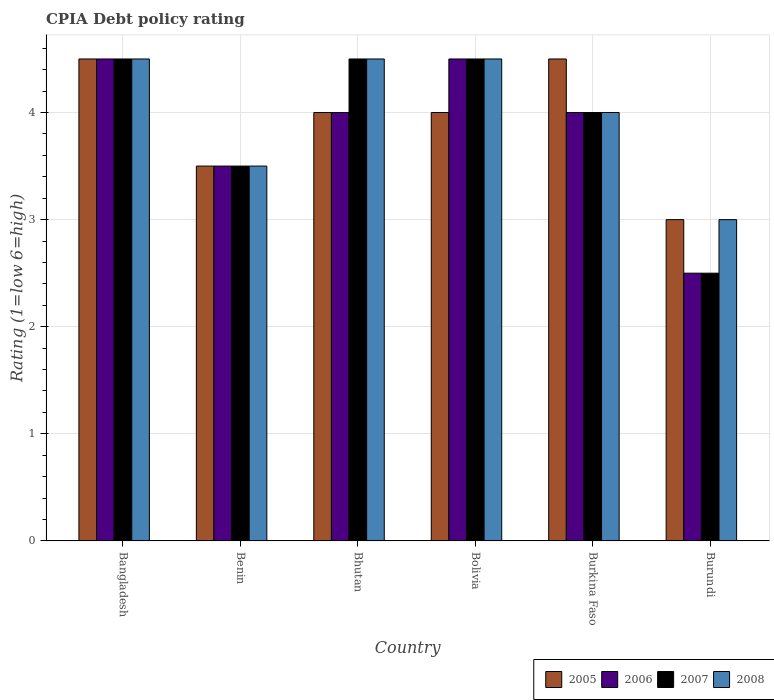Are the number of bars on each tick of the X-axis equal?
Ensure brevity in your answer.  Yes. How many bars are there on the 1st tick from the left?
Your response must be concise. 4. What is the label of the 1st group of bars from the left?
Ensure brevity in your answer.  Bangladesh. What is the CPIA rating in 2005 in Bolivia?
Your answer should be very brief. 4. Across all countries, what is the maximum CPIA rating in 2008?
Your response must be concise. 4.5. In which country was the CPIA rating in 2005 maximum?
Make the answer very short. Bangladesh. In which country was the CPIA rating in 2005 minimum?
Your response must be concise. Burundi. What is the total CPIA rating in 2005 in the graph?
Make the answer very short. 23.5. What is the difference between the CPIA rating of/in 2005 and CPIA rating of/in 2006 in Bolivia?
Give a very brief answer. -0.5. What is the difference between the highest and the second highest CPIA rating in 2005?
Your answer should be compact. 0.5. Is it the case that in every country, the sum of the CPIA rating in 2006 and CPIA rating in 2005 is greater than the sum of CPIA rating in 2008 and CPIA rating in 2007?
Give a very brief answer. No. Are all the bars in the graph horizontal?
Provide a short and direct response. No. How many countries are there in the graph?
Provide a short and direct response. 6. What is the difference between two consecutive major ticks on the Y-axis?
Provide a succinct answer. 1. Are the values on the major ticks of Y-axis written in scientific E-notation?
Give a very brief answer. No. Does the graph contain any zero values?
Ensure brevity in your answer.  No. How are the legend labels stacked?
Offer a very short reply. Horizontal. What is the title of the graph?
Ensure brevity in your answer.  CPIA Debt policy rating. What is the label or title of the Y-axis?
Offer a terse response. Rating (1=low 6=high). What is the Rating (1=low 6=high) of 2005 in Bangladesh?
Your response must be concise. 4.5. What is the Rating (1=low 6=high) in 2007 in Bangladesh?
Your answer should be compact. 4.5. What is the Rating (1=low 6=high) in 2008 in Bangladesh?
Your answer should be compact. 4.5. What is the Rating (1=low 6=high) of 2008 in Benin?
Offer a terse response. 3.5. What is the Rating (1=low 6=high) in 2005 in Bhutan?
Your answer should be compact. 4. What is the Rating (1=low 6=high) in 2006 in Bhutan?
Your answer should be compact. 4. What is the Rating (1=low 6=high) in 2008 in Bhutan?
Ensure brevity in your answer.  4.5. What is the Rating (1=low 6=high) in 2006 in Burkina Faso?
Your response must be concise. 4. What is the Rating (1=low 6=high) in 2007 in Burkina Faso?
Offer a terse response. 4. What is the Rating (1=low 6=high) of 2006 in Burundi?
Make the answer very short. 2.5. What is the Rating (1=low 6=high) of 2007 in Burundi?
Make the answer very short. 2.5. What is the Rating (1=low 6=high) of 2008 in Burundi?
Keep it short and to the point. 3. Across all countries, what is the maximum Rating (1=low 6=high) in 2005?
Ensure brevity in your answer.  4.5. Across all countries, what is the maximum Rating (1=low 6=high) of 2006?
Provide a succinct answer. 4.5. Across all countries, what is the minimum Rating (1=low 6=high) of 2006?
Give a very brief answer. 2.5. What is the total Rating (1=low 6=high) of 2006 in the graph?
Offer a very short reply. 23. What is the total Rating (1=low 6=high) in 2007 in the graph?
Your answer should be compact. 23.5. What is the difference between the Rating (1=low 6=high) of 2007 in Bangladesh and that in Benin?
Offer a very short reply. 1. What is the difference between the Rating (1=low 6=high) in 2008 in Bangladesh and that in Benin?
Your response must be concise. 1. What is the difference between the Rating (1=low 6=high) in 2005 in Bangladesh and that in Bhutan?
Offer a very short reply. 0.5. What is the difference between the Rating (1=low 6=high) in 2006 in Bangladesh and that in Bhutan?
Provide a short and direct response. 0.5. What is the difference between the Rating (1=low 6=high) of 2006 in Bangladesh and that in Bolivia?
Your answer should be compact. 0. What is the difference between the Rating (1=low 6=high) in 2007 in Bangladesh and that in Bolivia?
Provide a short and direct response. 0. What is the difference between the Rating (1=low 6=high) of 2007 in Bangladesh and that in Burkina Faso?
Ensure brevity in your answer.  0.5. What is the difference between the Rating (1=low 6=high) of 2006 in Bangladesh and that in Burundi?
Your response must be concise. 2. What is the difference between the Rating (1=low 6=high) of 2007 in Bangladesh and that in Burundi?
Make the answer very short. 2. What is the difference between the Rating (1=low 6=high) of 2005 in Benin and that in Bhutan?
Give a very brief answer. -0.5. What is the difference between the Rating (1=low 6=high) of 2007 in Benin and that in Bhutan?
Your answer should be compact. -1. What is the difference between the Rating (1=low 6=high) of 2005 in Benin and that in Bolivia?
Provide a succinct answer. -0.5. What is the difference between the Rating (1=low 6=high) of 2007 in Benin and that in Bolivia?
Make the answer very short. -1. What is the difference between the Rating (1=low 6=high) of 2008 in Benin and that in Bolivia?
Offer a terse response. -1. What is the difference between the Rating (1=low 6=high) of 2005 in Benin and that in Burkina Faso?
Offer a very short reply. -1. What is the difference between the Rating (1=low 6=high) of 2008 in Benin and that in Burundi?
Ensure brevity in your answer.  0.5. What is the difference between the Rating (1=low 6=high) of 2005 in Bhutan and that in Bolivia?
Make the answer very short. 0. What is the difference between the Rating (1=low 6=high) of 2006 in Bhutan and that in Bolivia?
Make the answer very short. -0.5. What is the difference between the Rating (1=low 6=high) in 2007 in Bhutan and that in Bolivia?
Your answer should be very brief. 0. What is the difference between the Rating (1=low 6=high) in 2006 in Bhutan and that in Burkina Faso?
Your response must be concise. 0. What is the difference between the Rating (1=low 6=high) of 2007 in Bhutan and that in Burkina Faso?
Give a very brief answer. 0.5. What is the difference between the Rating (1=low 6=high) of 2008 in Bhutan and that in Burkina Faso?
Keep it short and to the point. 0.5. What is the difference between the Rating (1=low 6=high) in 2007 in Bhutan and that in Burundi?
Ensure brevity in your answer.  2. What is the difference between the Rating (1=low 6=high) in 2006 in Bolivia and that in Burkina Faso?
Provide a short and direct response. 0.5. What is the difference between the Rating (1=low 6=high) of 2008 in Bolivia and that in Burkina Faso?
Provide a succinct answer. 0.5. What is the difference between the Rating (1=low 6=high) in 2006 in Bolivia and that in Burundi?
Your response must be concise. 2. What is the difference between the Rating (1=low 6=high) in 2008 in Bolivia and that in Burundi?
Your response must be concise. 1.5. What is the difference between the Rating (1=low 6=high) in 2007 in Burkina Faso and that in Burundi?
Provide a short and direct response. 1.5. What is the difference between the Rating (1=low 6=high) of 2005 in Bangladesh and the Rating (1=low 6=high) of 2006 in Benin?
Offer a terse response. 1. What is the difference between the Rating (1=low 6=high) of 2005 in Bangladesh and the Rating (1=low 6=high) of 2007 in Benin?
Your response must be concise. 1. What is the difference between the Rating (1=low 6=high) of 2006 in Bangladesh and the Rating (1=low 6=high) of 2007 in Benin?
Give a very brief answer. 1. What is the difference between the Rating (1=low 6=high) in 2007 in Bangladesh and the Rating (1=low 6=high) in 2008 in Benin?
Offer a very short reply. 1. What is the difference between the Rating (1=low 6=high) of 2005 in Bangladesh and the Rating (1=low 6=high) of 2006 in Bhutan?
Your answer should be very brief. 0.5. What is the difference between the Rating (1=low 6=high) in 2006 in Bangladesh and the Rating (1=low 6=high) in 2007 in Bhutan?
Provide a succinct answer. 0. What is the difference between the Rating (1=low 6=high) in 2006 in Bangladesh and the Rating (1=low 6=high) in 2008 in Bhutan?
Offer a terse response. 0. What is the difference between the Rating (1=low 6=high) of 2006 in Bangladesh and the Rating (1=low 6=high) of 2007 in Bolivia?
Make the answer very short. 0. What is the difference between the Rating (1=low 6=high) of 2006 in Bangladesh and the Rating (1=low 6=high) of 2008 in Bolivia?
Your answer should be compact. 0. What is the difference between the Rating (1=low 6=high) of 2005 in Bangladesh and the Rating (1=low 6=high) of 2007 in Burkina Faso?
Keep it short and to the point. 0.5. What is the difference between the Rating (1=low 6=high) in 2006 in Bangladesh and the Rating (1=low 6=high) in 2008 in Burkina Faso?
Offer a very short reply. 0.5. What is the difference between the Rating (1=low 6=high) in 2007 in Bangladesh and the Rating (1=low 6=high) in 2008 in Burkina Faso?
Provide a short and direct response. 0.5. What is the difference between the Rating (1=low 6=high) of 2005 in Bangladesh and the Rating (1=low 6=high) of 2006 in Burundi?
Offer a very short reply. 2. What is the difference between the Rating (1=low 6=high) in 2005 in Bangladesh and the Rating (1=low 6=high) in 2008 in Burundi?
Offer a terse response. 1.5. What is the difference between the Rating (1=low 6=high) of 2006 in Bangladesh and the Rating (1=low 6=high) of 2007 in Burundi?
Your answer should be very brief. 2. What is the difference between the Rating (1=low 6=high) in 2005 in Benin and the Rating (1=low 6=high) in 2006 in Bhutan?
Your answer should be very brief. -0.5. What is the difference between the Rating (1=low 6=high) in 2005 in Benin and the Rating (1=low 6=high) in 2007 in Bhutan?
Give a very brief answer. -1. What is the difference between the Rating (1=low 6=high) in 2006 in Benin and the Rating (1=low 6=high) in 2008 in Bhutan?
Your response must be concise. -1. What is the difference between the Rating (1=low 6=high) of 2007 in Benin and the Rating (1=low 6=high) of 2008 in Bhutan?
Provide a short and direct response. -1. What is the difference between the Rating (1=low 6=high) of 2006 in Benin and the Rating (1=low 6=high) of 2008 in Bolivia?
Keep it short and to the point. -1. What is the difference between the Rating (1=low 6=high) in 2005 in Benin and the Rating (1=low 6=high) in 2006 in Burkina Faso?
Offer a very short reply. -0.5. What is the difference between the Rating (1=low 6=high) of 2005 in Benin and the Rating (1=low 6=high) of 2008 in Burkina Faso?
Your answer should be compact. -0.5. What is the difference between the Rating (1=low 6=high) in 2006 in Benin and the Rating (1=low 6=high) in 2007 in Burkina Faso?
Give a very brief answer. -0.5. What is the difference between the Rating (1=low 6=high) of 2006 in Benin and the Rating (1=low 6=high) of 2008 in Burkina Faso?
Your response must be concise. -0.5. What is the difference between the Rating (1=low 6=high) in 2007 in Benin and the Rating (1=low 6=high) in 2008 in Burkina Faso?
Your response must be concise. -0.5. What is the difference between the Rating (1=low 6=high) in 2005 in Benin and the Rating (1=low 6=high) in 2006 in Burundi?
Offer a very short reply. 1. What is the difference between the Rating (1=low 6=high) in 2005 in Benin and the Rating (1=low 6=high) in 2007 in Burundi?
Make the answer very short. 1. What is the difference between the Rating (1=low 6=high) in 2005 in Benin and the Rating (1=low 6=high) in 2008 in Burundi?
Offer a terse response. 0.5. What is the difference between the Rating (1=low 6=high) in 2006 in Benin and the Rating (1=low 6=high) in 2007 in Burundi?
Make the answer very short. 1. What is the difference between the Rating (1=low 6=high) in 2007 in Benin and the Rating (1=low 6=high) in 2008 in Burundi?
Your response must be concise. 0.5. What is the difference between the Rating (1=low 6=high) of 2005 in Bhutan and the Rating (1=low 6=high) of 2006 in Bolivia?
Your answer should be compact. -0.5. What is the difference between the Rating (1=low 6=high) in 2005 in Bhutan and the Rating (1=low 6=high) in 2007 in Bolivia?
Your response must be concise. -0.5. What is the difference between the Rating (1=low 6=high) in 2006 in Bhutan and the Rating (1=low 6=high) in 2007 in Bolivia?
Your answer should be very brief. -0.5. What is the difference between the Rating (1=low 6=high) in 2006 in Bhutan and the Rating (1=low 6=high) in 2008 in Bolivia?
Keep it short and to the point. -0.5. What is the difference between the Rating (1=low 6=high) in 2005 in Bhutan and the Rating (1=low 6=high) in 2007 in Burkina Faso?
Ensure brevity in your answer.  0. What is the difference between the Rating (1=low 6=high) of 2006 in Bhutan and the Rating (1=low 6=high) of 2007 in Burkina Faso?
Your response must be concise. 0. What is the difference between the Rating (1=low 6=high) in 2006 in Bhutan and the Rating (1=low 6=high) in 2008 in Burkina Faso?
Offer a terse response. 0. What is the difference between the Rating (1=low 6=high) of 2006 in Bhutan and the Rating (1=low 6=high) of 2007 in Burundi?
Ensure brevity in your answer.  1.5. What is the difference between the Rating (1=low 6=high) of 2006 in Bhutan and the Rating (1=low 6=high) of 2008 in Burundi?
Your response must be concise. 1. What is the difference between the Rating (1=low 6=high) of 2005 in Bolivia and the Rating (1=low 6=high) of 2006 in Burkina Faso?
Your response must be concise. 0. What is the difference between the Rating (1=low 6=high) in 2006 in Bolivia and the Rating (1=low 6=high) in 2008 in Burkina Faso?
Your answer should be compact. 0.5. What is the difference between the Rating (1=low 6=high) of 2007 in Bolivia and the Rating (1=low 6=high) of 2008 in Burkina Faso?
Provide a short and direct response. 0.5. What is the difference between the Rating (1=low 6=high) of 2005 in Bolivia and the Rating (1=low 6=high) of 2006 in Burundi?
Your answer should be compact. 1.5. What is the difference between the Rating (1=low 6=high) of 2007 in Bolivia and the Rating (1=low 6=high) of 2008 in Burundi?
Provide a short and direct response. 1.5. What is the difference between the Rating (1=low 6=high) of 2005 in Burkina Faso and the Rating (1=low 6=high) of 2006 in Burundi?
Offer a very short reply. 2. What is the difference between the Rating (1=low 6=high) of 2005 in Burkina Faso and the Rating (1=low 6=high) of 2007 in Burundi?
Offer a very short reply. 2. What is the difference between the Rating (1=low 6=high) of 2006 in Burkina Faso and the Rating (1=low 6=high) of 2008 in Burundi?
Make the answer very short. 1. What is the average Rating (1=low 6=high) of 2005 per country?
Keep it short and to the point. 3.92. What is the average Rating (1=low 6=high) of 2006 per country?
Provide a short and direct response. 3.83. What is the average Rating (1=low 6=high) in 2007 per country?
Keep it short and to the point. 3.92. What is the average Rating (1=low 6=high) in 2008 per country?
Provide a succinct answer. 4. What is the difference between the Rating (1=low 6=high) of 2005 and Rating (1=low 6=high) of 2008 in Bangladesh?
Your answer should be very brief. 0. What is the difference between the Rating (1=low 6=high) in 2006 and Rating (1=low 6=high) in 2007 in Bangladesh?
Keep it short and to the point. 0. What is the difference between the Rating (1=low 6=high) of 2006 and Rating (1=low 6=high) of 2008 in Bangladesh?
Make the answer very short. 0. What is the difference between the Rating (1=low 6=high) of 2006 and Rating (1=low 6=high) of 2008 in Benin?
Keep it short and to the point. 0. What is the difference between the Rating (1=low 6=high) in 2007 and Rating (1=low 6=high) in 2008 in Benin?
Offer a terse response. 0. What is the difference between the Rating (1=low 6=high) of 2005 and Rating (1=low 6=high) of 2006 in Bhutan?
Ensure brevity in your answer.  0. What is the difference between the Rating (1=low 6=high) in 2005 and Rating (1=low 6=high) in 2007 in Bhutan?
Offer a terse response. -0.5. What is the difference between the Rating (1=low 6=high) of 2005 and Rating (1=low 6=high) of 2008 in Bhutan?
Give a very brief answer. -0.5. What is the difference between the Rating (1=low 6=high) of 2006 and Rating (1=low 6=high) of 2007 in Bhutan?
Keep it short and to the point. -0.5. What is the difference between the Rating (1=low 6=high) of 2007 and Rating (1=low 6=high) of 2008 in Bhutan?
Your answer should be very brief. 0. What is the difference between the Rating (1=low 6=high) of 2005 and Rating (1=low 6=high) of 2007 in Bolivia?
Give a very brief answer. -0.5. What is the difference between the Rating (1=low 6=high) in 2005 and Rating (1=low 6=high) in 2008 in Burkina Faso?
Offer a very short reply. 0.5. What is the difference between the Rating (1=low 6=high) of 2006 and Rating (1=low 6=high) of 2008 in Burkina Faso?
Keep it short and to the point. 0. What is the difference between the Rating (1=low 6=high) in 2005 and Rating (1=low 6=high) in 2008 in Burundi?
Provide a succinct answer. 0. What is the difference between the Rating (1=low 6=high) in 2006 and Rating (1=low 6=high) in 2007 in Burundi?
Provide a short and direct response. 0. What is the difference between the Rating (1=low 6=high) in 2007 and Rating (1=low 6=high) in 2008 in Burundi?
Ensure brevity in your answer.  -0.5. What is the ratio of the Rating (1=low 6=high) in 2005 in Bangladesh to that in Benin?
Provide a succinct answer. 1.29. What is the ratio of the Rating (1=low 6=high) of 2006 in Bangladesh to that in Benin?
Your response must be concise. 1.29. What is the ratio of the Rating (1=low 6=high) of 2008 in Bangladesh to that in Benin?
Ensure brevity in your answer.  1.29. What is the ratio of the Rating (1=low 6=high) of 2006 in Bangladesh to that in Bhutan?
Provide a succinct answer. 1.12. What is the ratio of the Rating (1=low 6=high) in 2007 in Bangladesh to that in Bhutan?
Give a very brief answer. 1. What is the ratio of the Rating (1=low 6=high) in 2005 in Bangladesh to that in Bolivia?
Your answer should be very brief. 1.12. What is the ratio of the Rating (1=low 6=high) in 2007 in Bangladesh to that in Bolivia?
Keep it short and to the point. 1. What is the ratio of the Rating (1=low 6=high) of 2008 in Bangladesh to that in Bolivia?
Give a very brief answer. 1. What is the ratio of the Rating (1=low 6=high) in 2005 in Bangladesh to that in Burkina Faso?
Make the answer very short. 1. What is the ratio of the Rating (1=low 6=high) in 2007 in Bangladesh to that in Burkina Faso?
Provide a succinct answer. 1.12. What is the ratio of the Rating (1=low 6=high) in 2005 in Bangladesh to that in Burundi?
Make the answer very short. 1.5. What is the ratio of the Rating (1=low 6=high) of 2006 in Bangladesh to that in Burundi?
Provide a succinct answer. 1.8. What is the ratio of the Rating (1=low 6=high) of 2006 in Benin to that in Bhutan?
Provide a succinct answer. 0.88. What is the ratio of the Rating (1=low 6=high) in 2008 in Benin to that in Bhutan?
Give a very brief answer. 0.78. What is the ratio of the Rating (1=low 6=high) in 2005 in Benin to that in Bolivia?
Keep it short and to the point. 0.88. What is the ratio of the Rating (1=low 6=high) in 2006 in Benin to that in Bolivia?
Provide a succinct answer. 0.78. What is the ratio of the Rating (1=low 6=high) in 2007 in Benin to that in Bolivia?
Keep it short and to the point. 0.78. What is the ratio of the Rating (1=low 6=high) of 2008 in Benin to that in Bolivia?
Provide a short and direct response. 0.78. What is the ratio of the Rating (1=low 6=high) of 2006 in Benin to that in Burkina Faso?
Your response must be concise. 0.88. What is the ratio of the Rating (1=low 6=high) in 2007 in Benin to that in Burkina Faso?
Offer a terse response. 0.88. What is the ratio of the Rating (1=low 6=high) of 2008 in Benin to that in Burkina Faso?
Offer a terse response. 0.88. What is the ratio of the Rating (1=low 6=high) in 2005 in Benin to that in Burundi?
Provide a short and direct response. 1.17. What is the ratio of the Rating (1=low 6=high) of 2005 in Bhutan to that in Bolivia?
Your answer should be very brief. 1. What is the ratio of the Rating (1=low 6=high) in 2008 in Bhutan to that in Bolivia?
Keep it short and to the point. 1. What is the ratio of the Rating (1=low 6=high) in 2006 in Bhutan to that in Burkina Faso?
Your answer should be compact. 1. What is the ratio of the Rating (1=low 6=high) of 2005 in Bhutan to that in Burundi?
Your answer should be compact. 1.33. What is the ratio of the Rating (1=low 6=high) of 2007 in Bhutan to that in Burundi?
Offer a terse response. 1.8. What is the ratio of the Rating (1=low 6=high) of 2005 in Bolivia to that in Burkina Faso?
Offer a terse response. 0.89. What is the ratio of the Rating (1=low 6=high) in 2007 in Bolivia to that in Burkina Faso?
Offer a very short reply. 1.12. What is the ratio of the Rating (1=low 6=high) of 2007 in Bolivia to that in Burundi?
Offer a terse response. 1.8. What is the ratio of the Rating (1=low 6=high) in 2008 in Bolivia to that in Burundi?
Your answer should be very brief. 1.5. What is the ratio of the Rating (1=low 6=high) in 2005 in Burkina Faso to that in Burundi?
Provide a succinct answer. 1.5. What is the difference between the highest and the second highest Rating (1=low 6=high) of 2005?
Ensure brevity in your answer.  0. What is the difference between the highest and the second highest Rating (1=low 6=high) of 2006?
Offer a terse response. 0. What is the difference between the highest and the second highest Rating (1=low 6=high) in 2007?
Offer a terse response. 0. What is the difference between the highest and the second highest Rating (1=low 6=high) of 2008?
Provide a short and direct response. 0. What is the difference between the highest and the lowest Rating (1=low 6=high) of 2005?
Your answer should be very brief. 1.5. What is the difference between the highest and the lowest Rating (1=low 6=high) of 2007?
Offer a very short reply. 2. What is the difference between the highest and the lowest Rating (1=low 6=high) in 2008?
Offer a terse response. 1.5. 